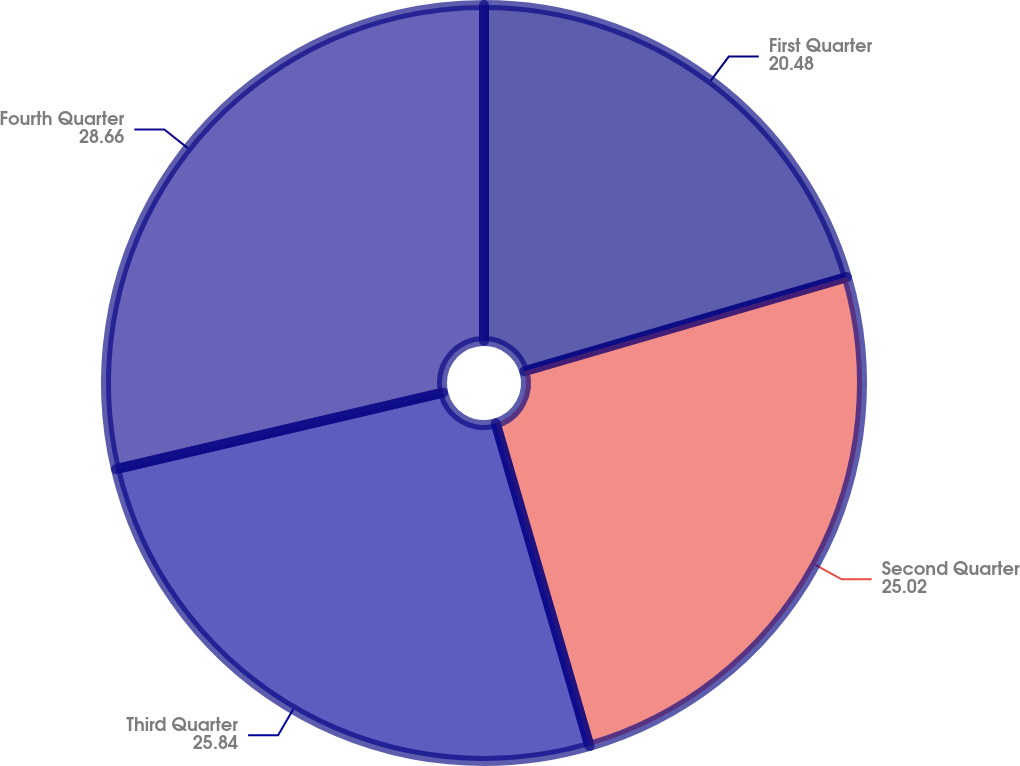Convert chart to OTSL. <chart><loc_0><loc_0><loc_500><loc_500><pie_chart><fcel>First Quarter<fcel>Second Quarter<fcel>Third Quarter<fcel>Fourth Quarter<nl><fcel>20.48%<fcel>25.02%<fcel>25.84%<fcel>28.66%<nl></chart> 